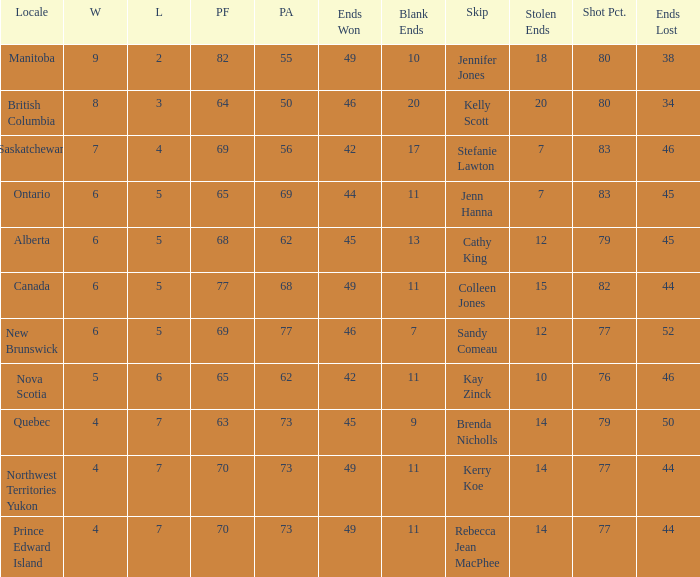Help me parse the entirety of this table. {'header': ['Locale', 'W', 'L', 'PF', 'PA', 'Ends Won', 'Blank Ends', 'Skip', 'Stolen Ends', 'Shot Pct.', 'Ends Lost'], 'rows': [['Manitoba', '9', '2', '82', '55', '49', '10', 'Jennifer Jones', '18', '80', '38'], ['British Columbia', '8', '3', '64', '50', '46', '20', 'Kelly Scott', '20', '80', '34'], ['Saskatchewan', '7', '4', '69', '56', '42', '17', 'Stefanie Lawton', '7', '83', '46'], ['Ontario', '6', '5', '65', '69', '44', '11', 'Jenn Hanna', '7', '83', '45'], ['Alberta', '6', '5', '68', '62', '45', '13', 'Cathy King', '12', '79', '45'], ['Canada', '6', '5', '77', '68', '49', '11', 'Colleen Jones', '15', '82', '44'], ['New Brunswick', '6', '5', '69', '77', '46', '7', 'Sandy Comeau', '12', '77', '52'], ['Nova Scotia', '5', '6', '65', '62', '42', '11', 'Kay Zinck', '10', '76', '46'], ['Quebec', '4', '7', '63', '73', '45', '9', 'Brenda Nicholls', '14', '79', '50'], ['Northwest Territories Yukon', '4', '7', '70', '73', '49', '11', 'Kerry Koe', '14', '77', '44'], ['Prince Edward Island', '4', '7', '70', '73', '49', '11', 'Rebecca Jean MacPhee', '14', '77', '44']]} What is the PA when the skip is Colleen Jones? 68.0. 